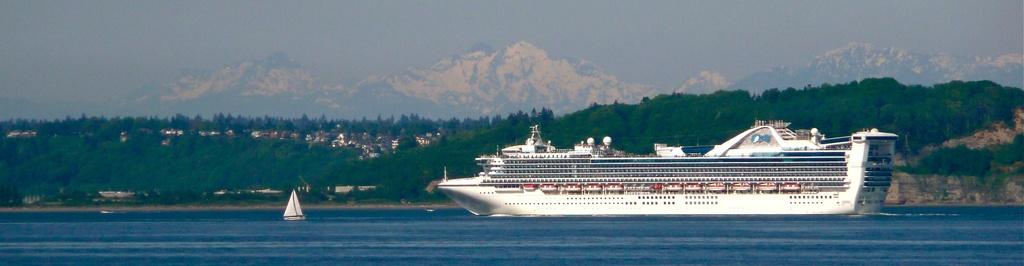What type of watercraft can be seen in the image? There is a boat and a ship in the image. Where are the boat and ship located? Both the boat and ship are in the sea. What can be seen in the background of the image? There are houses, trees, and mountains in the background of the image. What part of the natural environment is visible in the image? The sky is visible in the image. What is the temper of the tree in the image? There is no tree present in the image; it features a boat, a ship, and various background elements. 